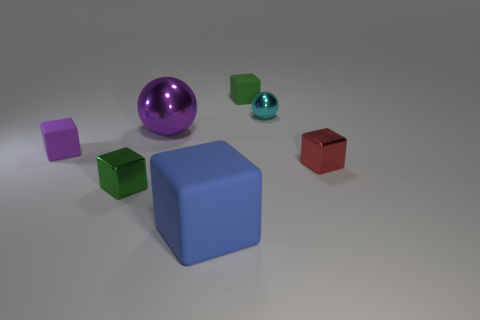Subtract all blue blocks. How many blocks are left? 4 Subtract all tiny green matte blocks. How many blocks are left? 4 Subtract all gray blocks. Subtract all cyan cylinders. How many blocks are left? 5 Add 1 rubber balls. How many objects exist? 8 Subtract all blocks. How many objects are left? 2 Subtract 0 green cylinders. How many objects are left? 7 Subtract all blue matte objects. Subtract all big balls. How many objects are left? 5 Add 2 big matte objects. How many big matte objects are left? 3 Add 1 large rubber blocks. How many large rubber blocks exist? 2 